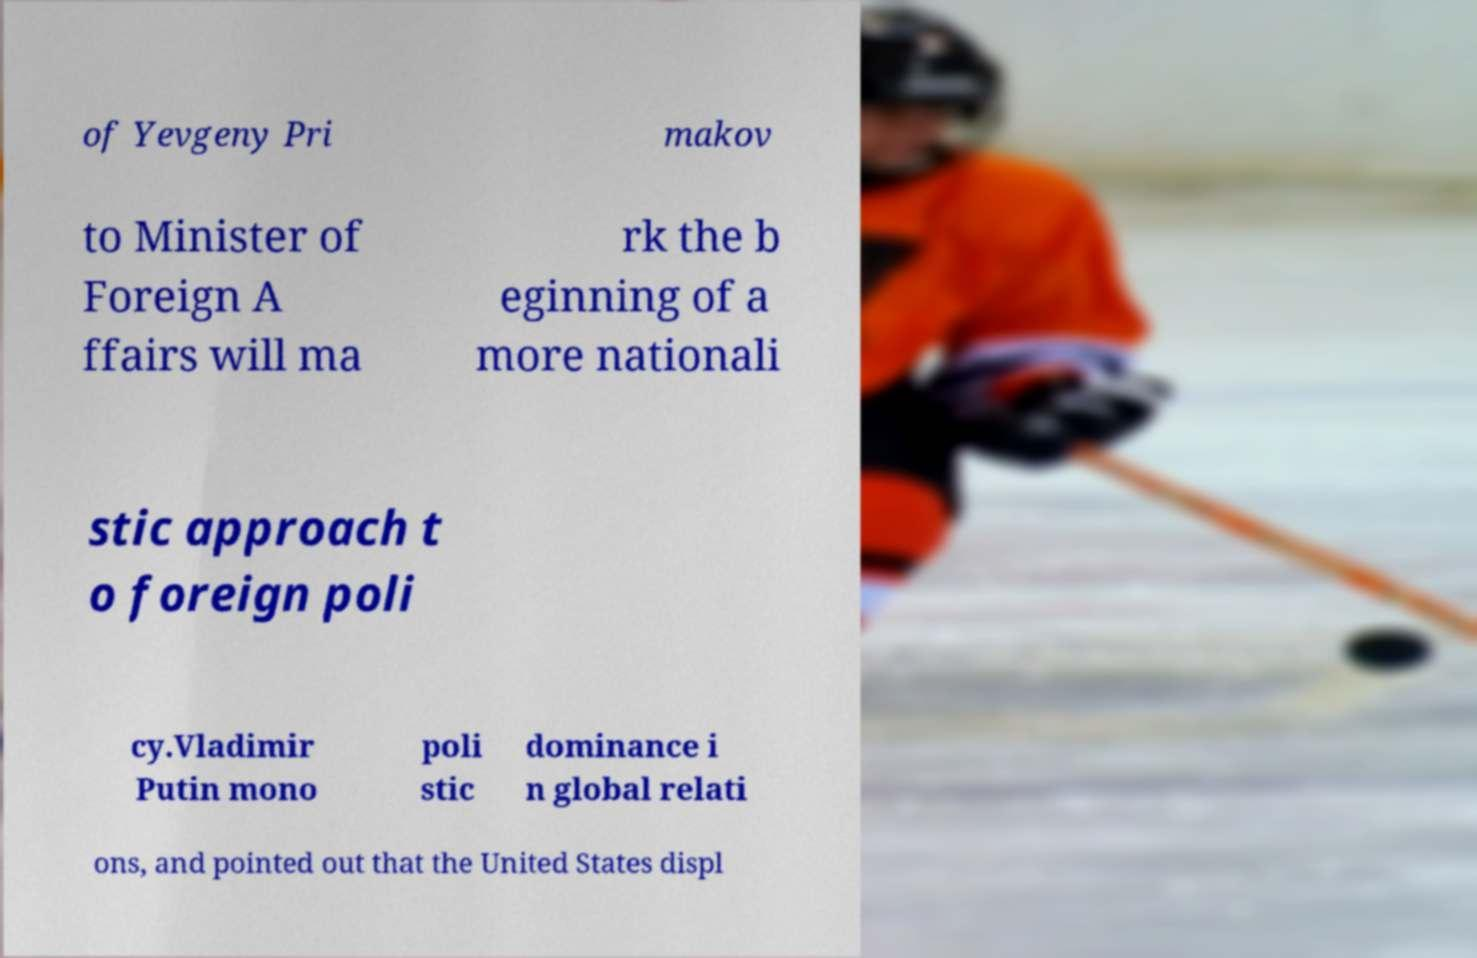There's text embedded in this image that I need extracted. Can you transcribe it verbatim? of Yevgeny Pri makov to Minister of Foreign A ffairs will ma rk the b eginning of a more nationali stic approach t o foreign poli cy.Vladimir Putin mono poli stic dominance i n global relati ons, and pointed out that the United States displ 